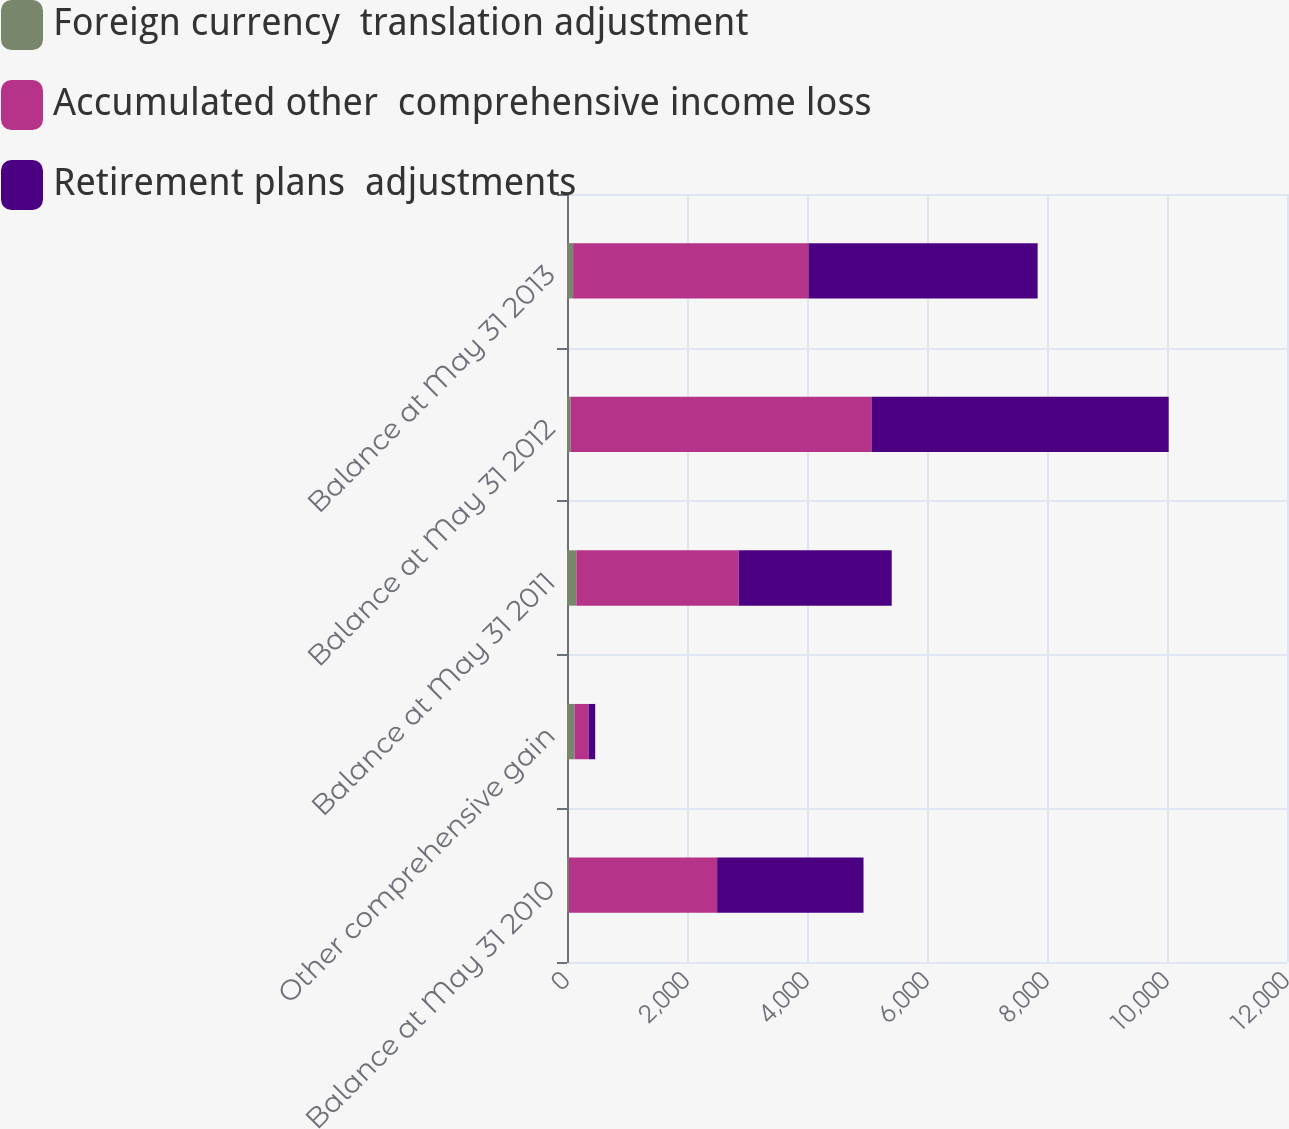<chart> <loc_0><loc_0><loc_500><loc_500><stacked_bar_chart><ecel><fcel>Balance at May 31 2010<fcel>Other comprehensive gain<fcel>Balance at May 31 2011<fcel>Balance at May 31 2012<fcel>Balance at May 31 2013<nl><fcel>Foreign currency  translation adjustment<fcel>31<fcel>125<fcel>156<fcel>61<fcel>102<nl><fcel>Accumulated other  comprehensive income loss<fcel>2471<fcel>235<fcel>2706<fcel>5014<fcel>3922<nl><fcel>Retirement plans  adjustments<fcel>2440<fcel>110<fcel>2550<fcel>4953<fcel>3820<nl></chart> 